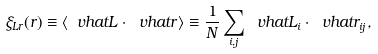<formula> <loc_0><loc_0><loc_500><loc_500>\xi _ { L r } ( r ) \equiv \left < \ v h a t { L } \cdot \ v h a t { r } \right > \equiv \frac { 1 } { N } \sum _ { i , j } \ v h a t { L } _ { i } \cdot \ v h a t { r } _ { i j } ,</formula> 